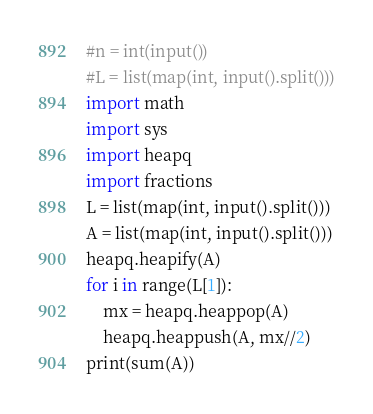Convert code to text. <code><loc_0><loc_0><loc_500><loc_500><_Python_>#n = int(input())
#L = list(map(int, input().split()))
import math
import sys
import heapq
import fractions
L = list(map(int, input().split()))
A = list(map(int, input().split()))
heapq.heapify(A)
for i in range(L[1]):
    mx = heapq.heappop(A)
    heapq.heappush(A, mx//2)
print(sum(A))</code> 